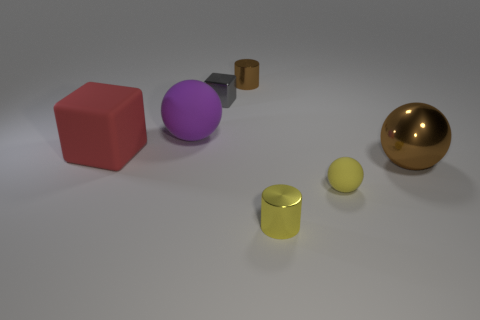There is a tiny object that is right of the gray metallic thing and behind the big brown thing; what is it made of? metal 